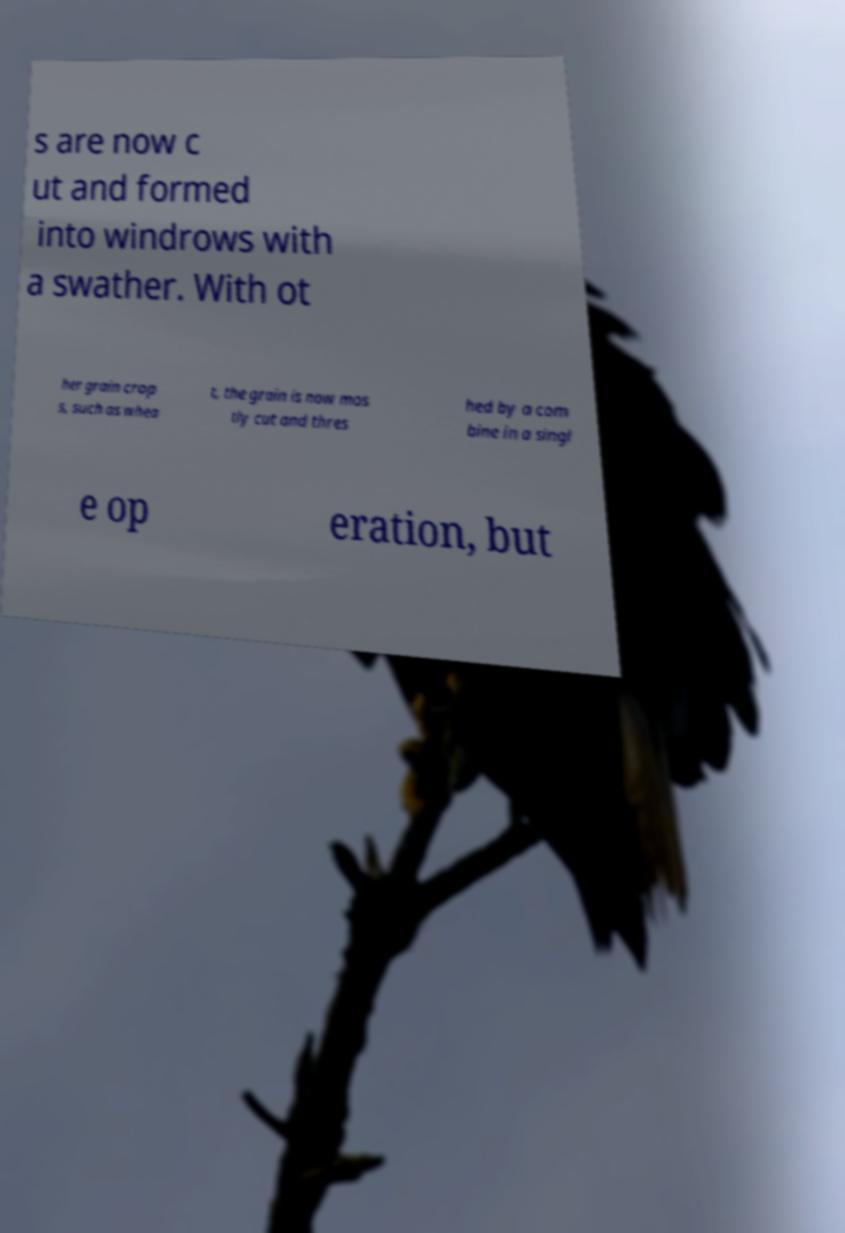There's text embedded in this image that I need extracted. Can you transcribe it verbatim? s are now c ut and formed into windrows with a swather. With ot her grain crop s, such as whea t, the grain is now mos tly cut and thres hed by a com bine in a singl e op eration, but 